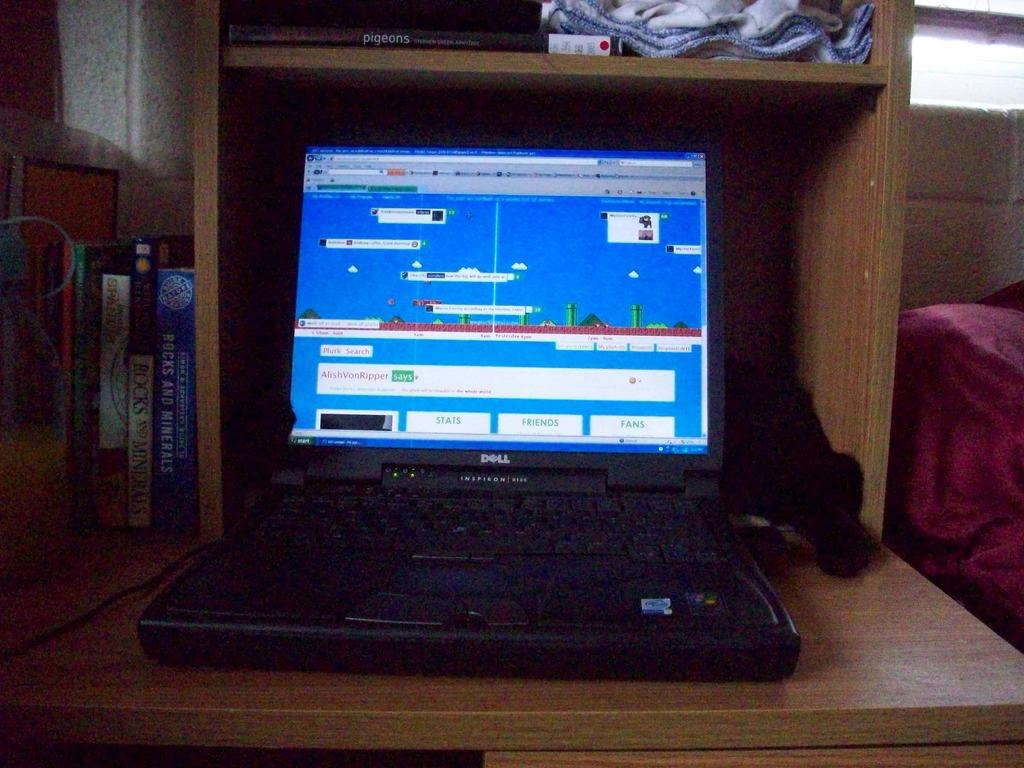<image>
Share a concise interpretation of the image provided. A black laptop with a display screen that has a box that sayas AlishVonRipper says 